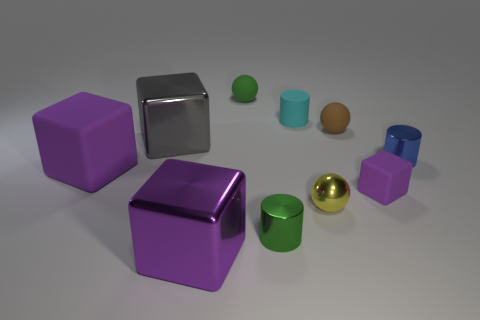Subtract all purple spheres. How many purple blocks are left? 3 Subtract all cylinders. How many objects are left? 7 Subtract all purple things. Subtract all yellow objects. How many objects are left? 6 Add 4 cyan objects. How many cyan objects are left? 5 Add 8 brown matte spheres. How many brown matte spheres exist? 9 Subtract 0 brown blocks. How many objects are left? 10 